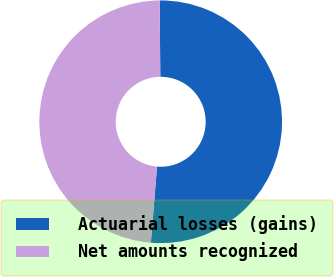Convert chart. <chart><loc_0><loc_0><loc_500><loc_500><pie_chart><fcel>Actuarial losses (gains)<fcel>Net amounts recognized<nl><fcel>51.43%<fcel>48.57%<nl></chart> 